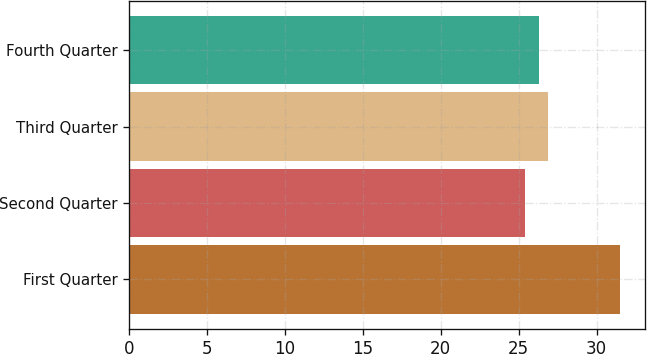<chart> <loc_0><loc_0><loc_500><loc_500><bar_chart><fcel>First Quarter<fcel>Second Quarter<fcel>Third Quarter<fcel>Fourth Quarter<nl><fcel>31.53<fcel>25.44<fcel>26.9<fcel>26.29<nl></chart> 